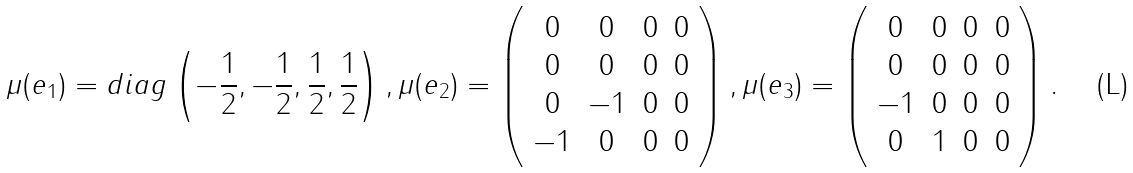<formula> <loc_0><loc_0><loc_500><loc_500>\mu ( e _ { 1 } ) = d i a g \left ( - \frac { 1 } { 2 } , - \frac { 1 } { 2 } , \frac { 1 } { 2 } , \frac { 1 } { 2 } \right ) , \mu ( e _ { 2 } ) = \left ( \begin{array} { c c c c } 0 & 0 & 0 & 0 \\ 0 & 0 & 0 & 0 \\ 0 & - 1 & 0 & 0 \\ - 1 & 0 & 0 & 0 \\ \end{array} \right ) , \mu ( e _ { 3 } ) = \left ( \begin{array} { c c c c } 0 & 0 & 0 & 0 \\ 0 & 0 & 0 & 0 \\ - 1 & 0 & 0 & 0 \\ 0 & 1 & 0 & 0 \\ \end{array} \right ) .</formula> 